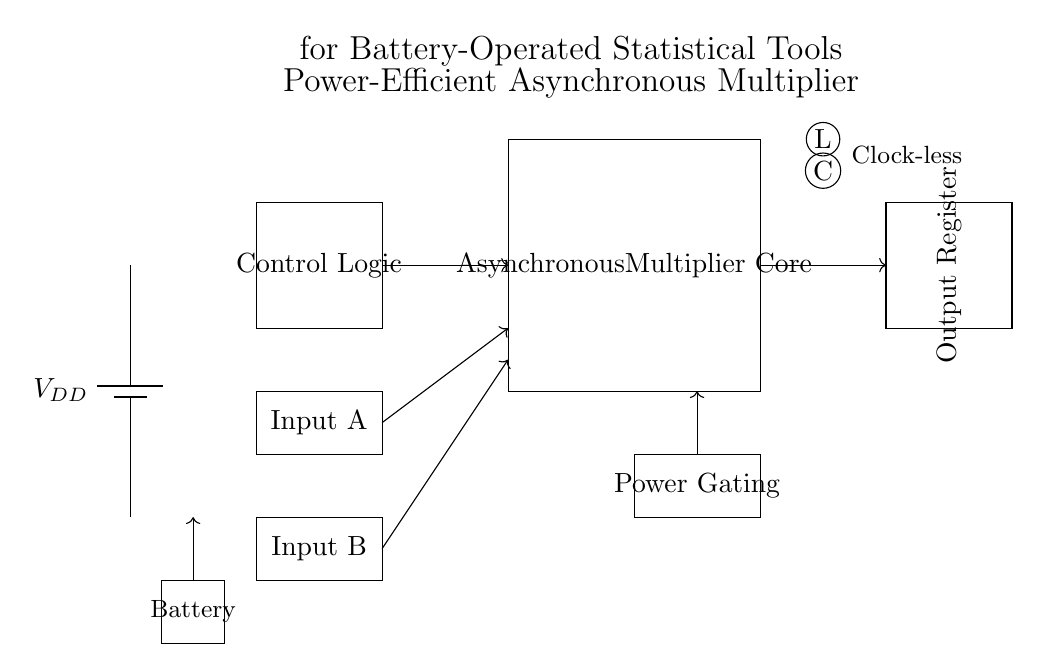What component supplies power in this circuit? The component that supplies power is the battery labeled as VDD, which provides the necessary voltage for the operation of the circuit.
Answer: battery What is the purpose of the Control Logic block? The Control Logic block is responsible for managing the operation and interactions between the components of the asynchronous multiplier, ensuring efficient processing without a clock signal.
Answer: managing operations How many connections are made to the Asynchronous Multiplier Core? There are three connections made to the Asynchronous Multiplier Core: one for each input from Input A, Input B, and the control logic.
Answer: three connections What type of operation does this circuit perform? The circuit performs multiplication as indicated by the label "Asynchronous Multiplier Core," which highlights its primary function.
Answer: multiplication What is indicated by the terms "Clock-less" in this circuit? The term "Clock-less" indicates that the asynchronous circuit operates without a global clock signal, relying on signal changes and local control for timing.
Answer: asynchronous operation What is the function of the Power Gating section in the circuit? The Power Gating section is implemented to save energy by turning off portions of the circuit that are not in use, thereby optimizing power efficiency for battery-operated devices.
Answer: energy saving What type of devices is this circuit intended for? This circuit is designed for battery-operated statistical tools, as specified in the title, which suggests its application in low-power computational devices.
Answer: statistical tools 